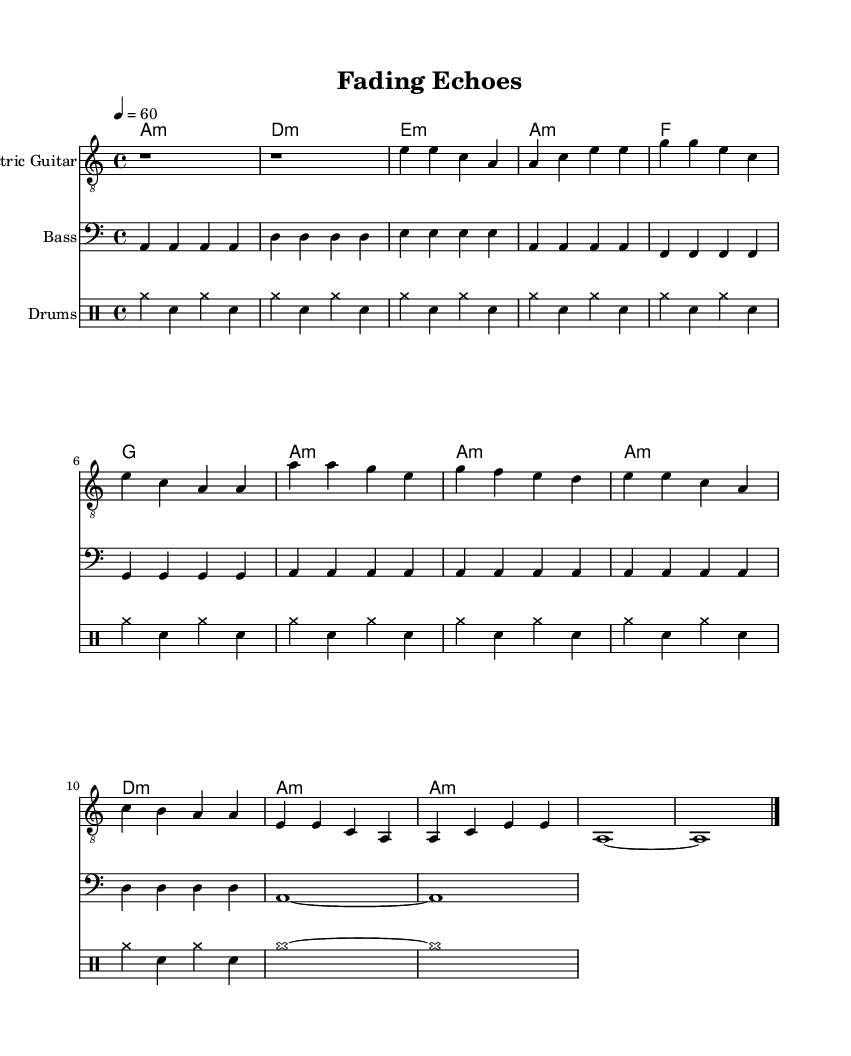What is the key signature of this music? The key signature is indicated by the presence of accidentals. In this piece, it shows A minor, as it has no sharps or flats.
Answer: A minor What is the time signature of this music? The time signature is shown at the beginning of the score. In this case, it is 4/4, which means there are four beats in each measure.
Answer: 4/4 What is the tempo marking for this piece? The tempo is indicated with a number that signifies beats per minute. Here, it is marked as 60 beats per minute.
Answer: 60 Which section follows the chorus? By looking at the structure of the piece, after the chorus listed directly in the score, it transitions into Verse 2, making it the section that follows.
Answer: Verse 2 How many measures are in the intro? The intro is defined at the beginning of the piece, consisting of two rests, each lasting one whole note, thus totaling two measures.
Answer: 2 What is the predominant theme explored in this piece? The title "Fading Echoes" suggests the theme of exploring memories and the passage of time reflected in the music's structure and mood. This can further be interpreted through the introspective feel of the verses and melody.
Answer: Memories 